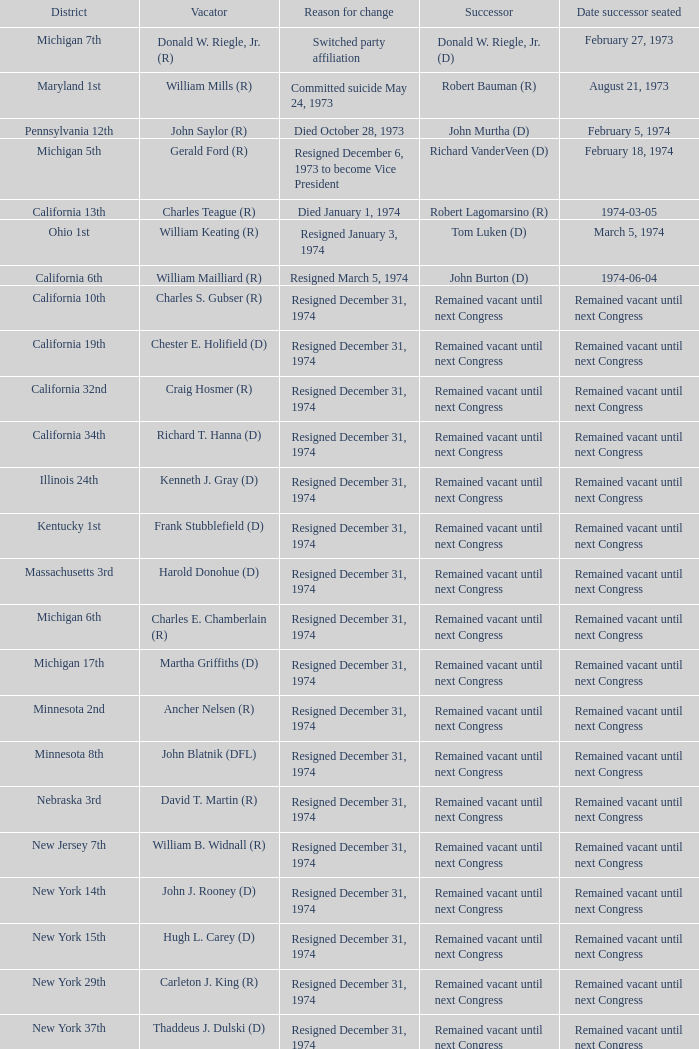When was the date successor appointed when the vacator was charles e. chamberlain (r)? Remained vacant until next Congress. 